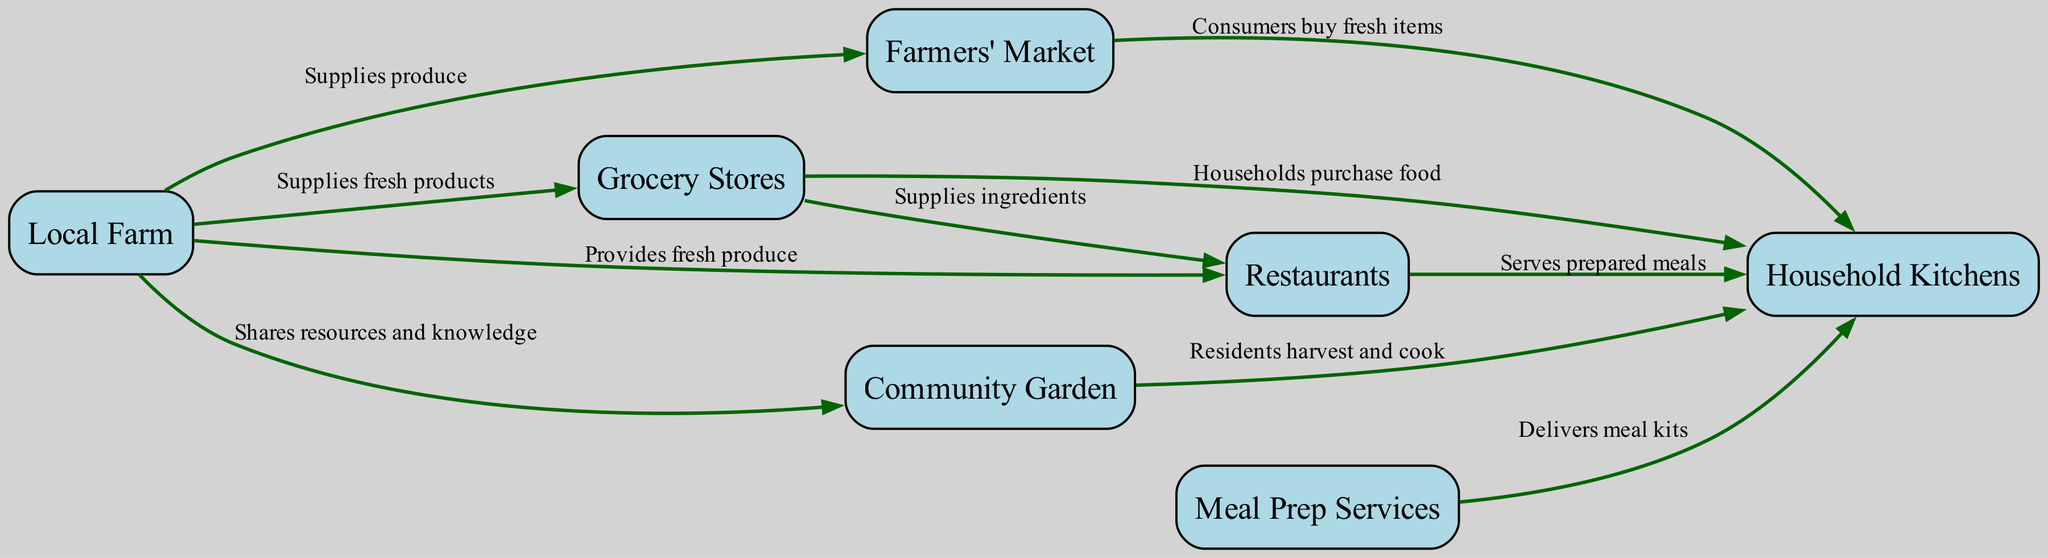What is the central node in the food chain? The central node, which connects various elements of the urban food chain, is "household kitchens." This is where the majority of the food from different sources eventually ends up, indicating its significance in the diagram.
Answer: household kitchens How many nodes are present in the diagram? By counting the unique nodes in the diagram, which include local farm, farmers' market, grocery stores, community garden, meal prep services, restaurants, and household kitchens, we find a total of seven nodes.
Answer: 7 Which node supplies the most sources? The "local farm" node links to multiple destinations, including farmers' market, grocery stores, community garden, and restaurants, making it the source supplying the most connections to other nodes.
Answer: local farm What is delivered by meal prep services to household kitchens? The meal prep services provide "meal kits" that contain pre-portioned ingredients and recipes directly to households, facilitating easier meal preparation.
Answer: meal kits From which node do grocery stores receive ingredients for restaurants? The grocery stores obtain ingredients for restaurants directly from "local farms," as indicated by the edge connecting these two nodes, showing the flow of supplies in the food chain.
Answer: local farms How many edges are connected to "household kitchens"? By analyzing the edges, we see that household kitchens connect to community garden, grocery stores, farmers' market, meal prep services, and restaurants, totaling five incoming edges.
Answer: 5 Which node does not directly supply household kitchens? The "community garden" does not directly supply household kitchens as it mainly indicates resources shared amongst residents rather than a direct supply line.
Answer: community garden How do local farms contribute to restaurants? Local farms "provide fresh produce" to restaurants, establishing a direct connection that highlights their role in sourcing ingredients for dining establishments.
Answer: provide fresh produce What type of gardens exist within local communities? "Community gardens" are the type of gardens that allow residents to cultivate their own food, promoting local food production and community involvement.
Answer: community gardens 